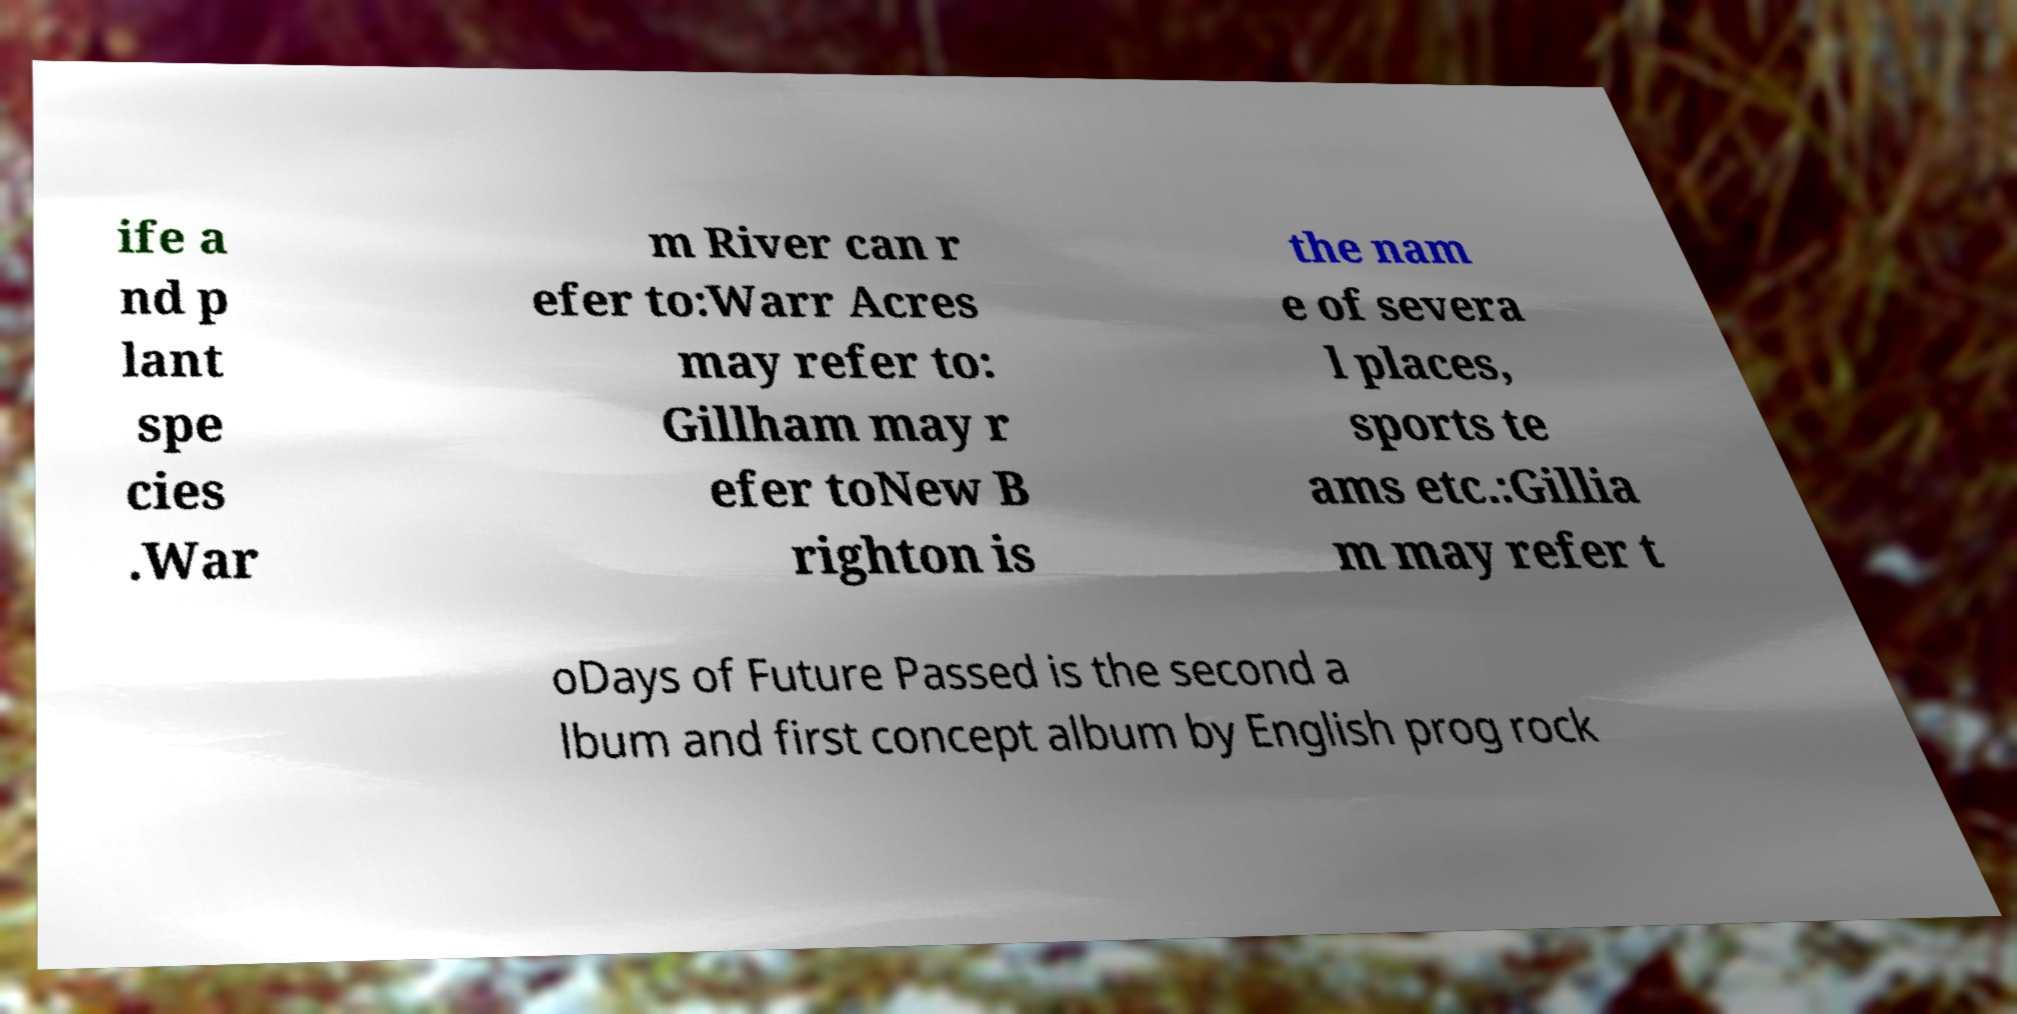Could you assist in decoding the text presented in this image and type it out clearly? ife a nd p lant spe cies .War m River can r efer to:Warr Acres may refer to: Gillham may r efer toNew B righton is the nam e of severa l places, sports te ams etc.:Gillia m may refer t oDays of Future Passed is the second a lbum and first concept album by English prog rock 